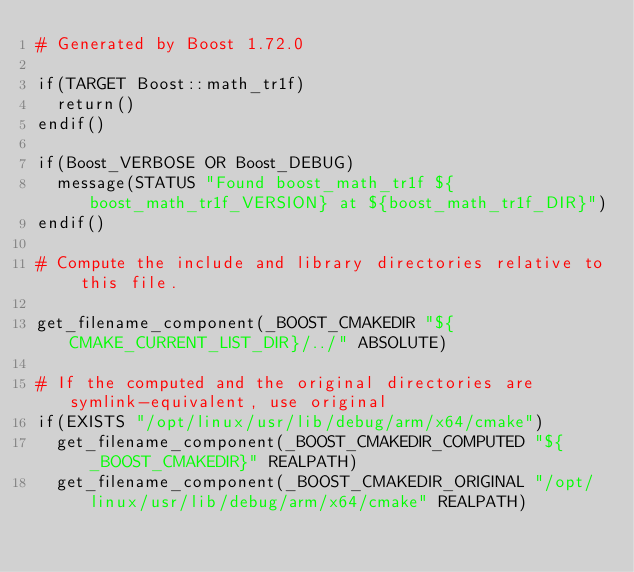<code> <loc_0><loc_0><loc_500><loc_500><_CMake_># Generated by Boost 1.72.0

if(TARGET Boost::math_tr1f)
  return()
endif()

if(Boost_VERBOSE OR Boost_DEBUG)
  message(STATUS "Found boost_math_tr1f ${boost_math_tr1f_VERSION} at ${boost_math_tr1f_DIR}")
endif()

# Compute the include and library directories relative to this file.

get_filename_component(_BOOST_CMAKEDIR "${CMAKE_CURRENT_LIST_DIR}/../" ABSOLUTE)

# If the computed and the original directories are symlink-equivalent, use original
if(EXISTS "/opt/linux/usr/lib/debug/arm/x64/cmake")
  get_filename_component(_BOOST_CMAKEDIR_COMPUTED "${_BOOST_CMAKEDIR}" REALPATH)
  get_filename_component(_BOOST_CMAKEDIR_ORIGINAL "/opt/linux/usr/lib/debug/arm/x64/cmake" REALPATH)</code> 